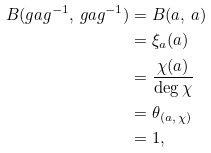Convert formula to latex. <formula><loc_0><loc_0><loc_500><loc_500>B _ { \L } ( g a g ^ { - 1 } , \, g a g ^ { - 1 } ) & = B _ { \L } ( a , \, a ) \\ & = \xi _ { a } ( a ) \\ & = \frac { \chi ( a ) } { \deg \chi } \\ & = \theta _ { ( a , \, \chi ) } \\ & = 1 ,</formula> 